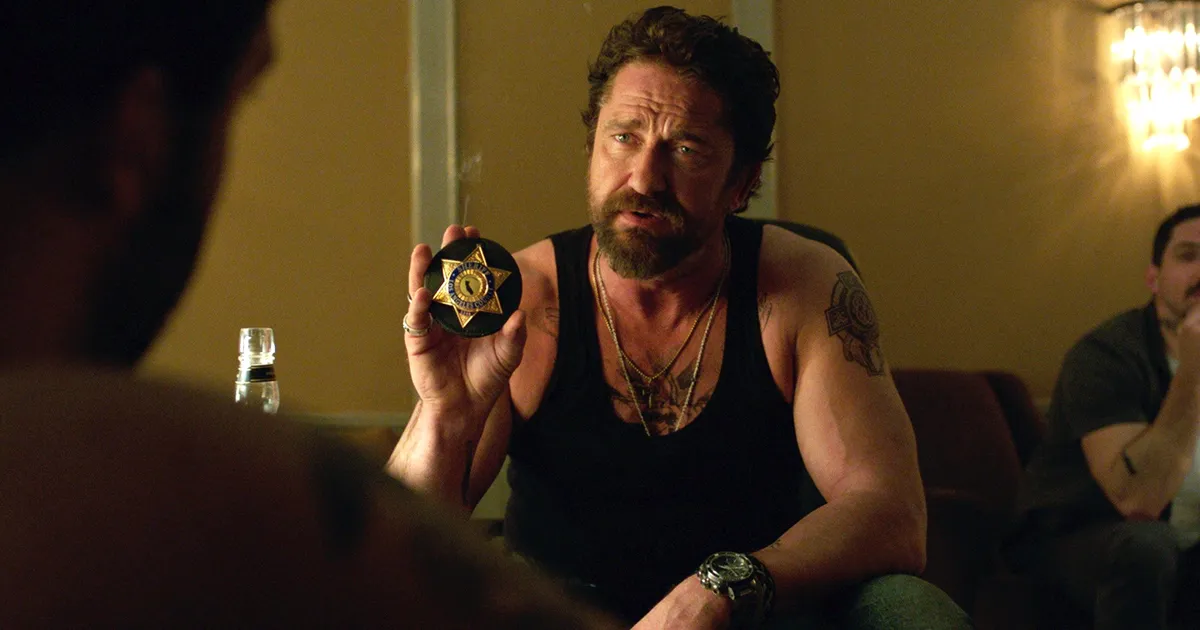What might be the significance of the badge the man is holding? The badge represents authority and law enforcement, typically indicating that the character is a police officer or detective. This badge likely serves as a pivotal prop in the narrative, establishing the character's identity and legal powers within the story. What does his attire and appearance say about his character? His rugged attire, including a tank top and visible tattoos, combined with a weary expression and unkempt beard, portray a character who might be tough, experienced, and possibly dealing with intense personal or professional challenges. This style usually suggests a character with a strong will and perhaps a history of complex, gritty experiences. 